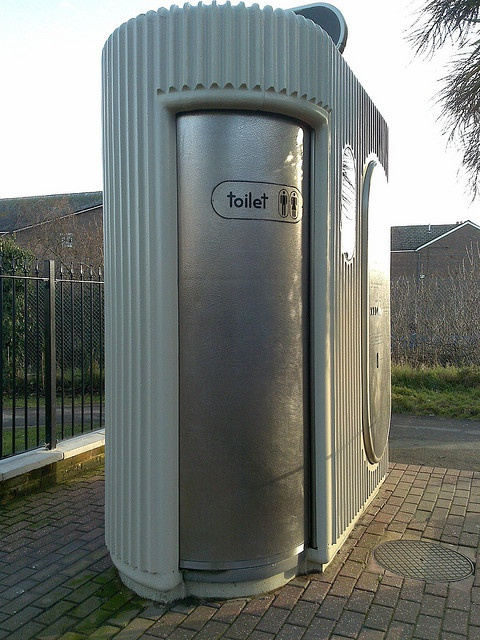Describe the objects in this image and their specific colors. I can see a toilet in white, gray, black, and darkgray tones in this image. 